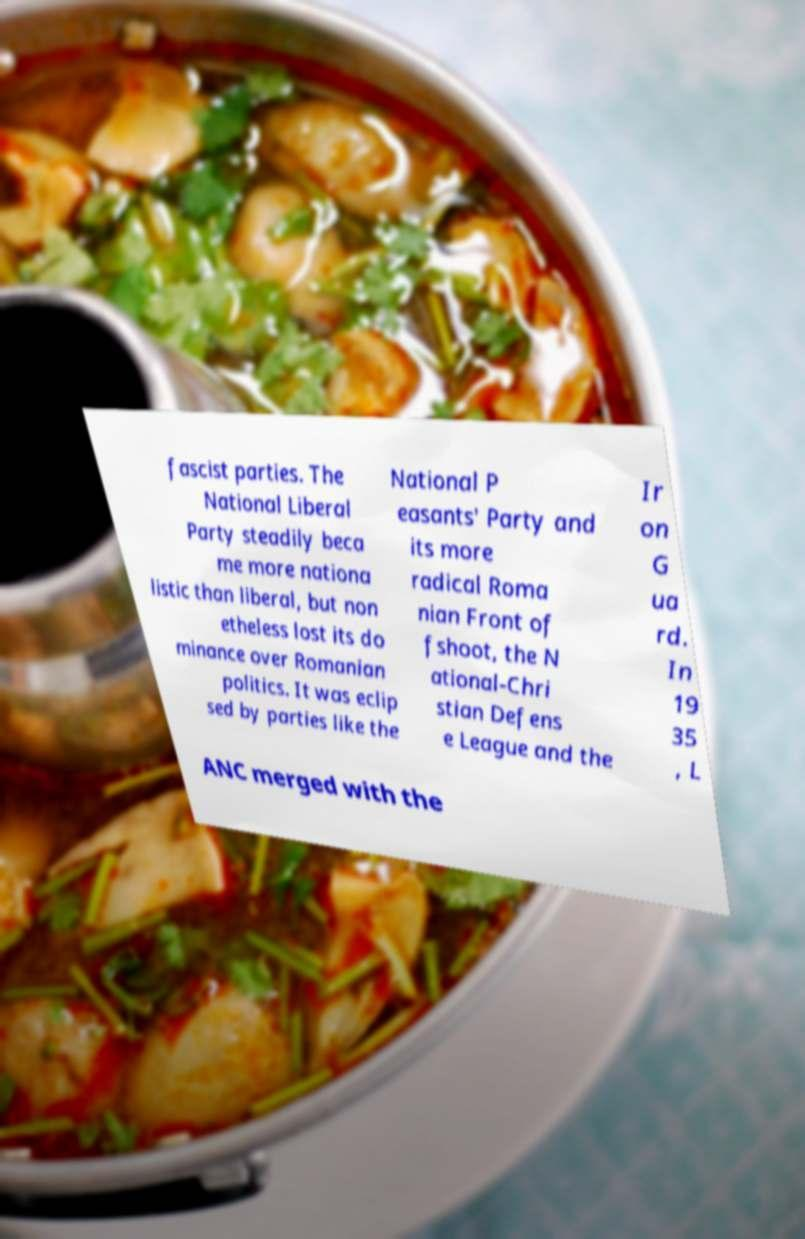Could you extract and type out the text from this image? fascist parties. The National Liberal Party steadily beca me more nationa listic than liberal, but non etheless lost its do minance over Romanian politics. It was eclip sed by parties like the National P easants' Party and its more radical Roma nian Front of fshoot, the N ational-Chri stian Defens e League and the Ir on G ua rd. In 19 35 , L ANC merged with the 